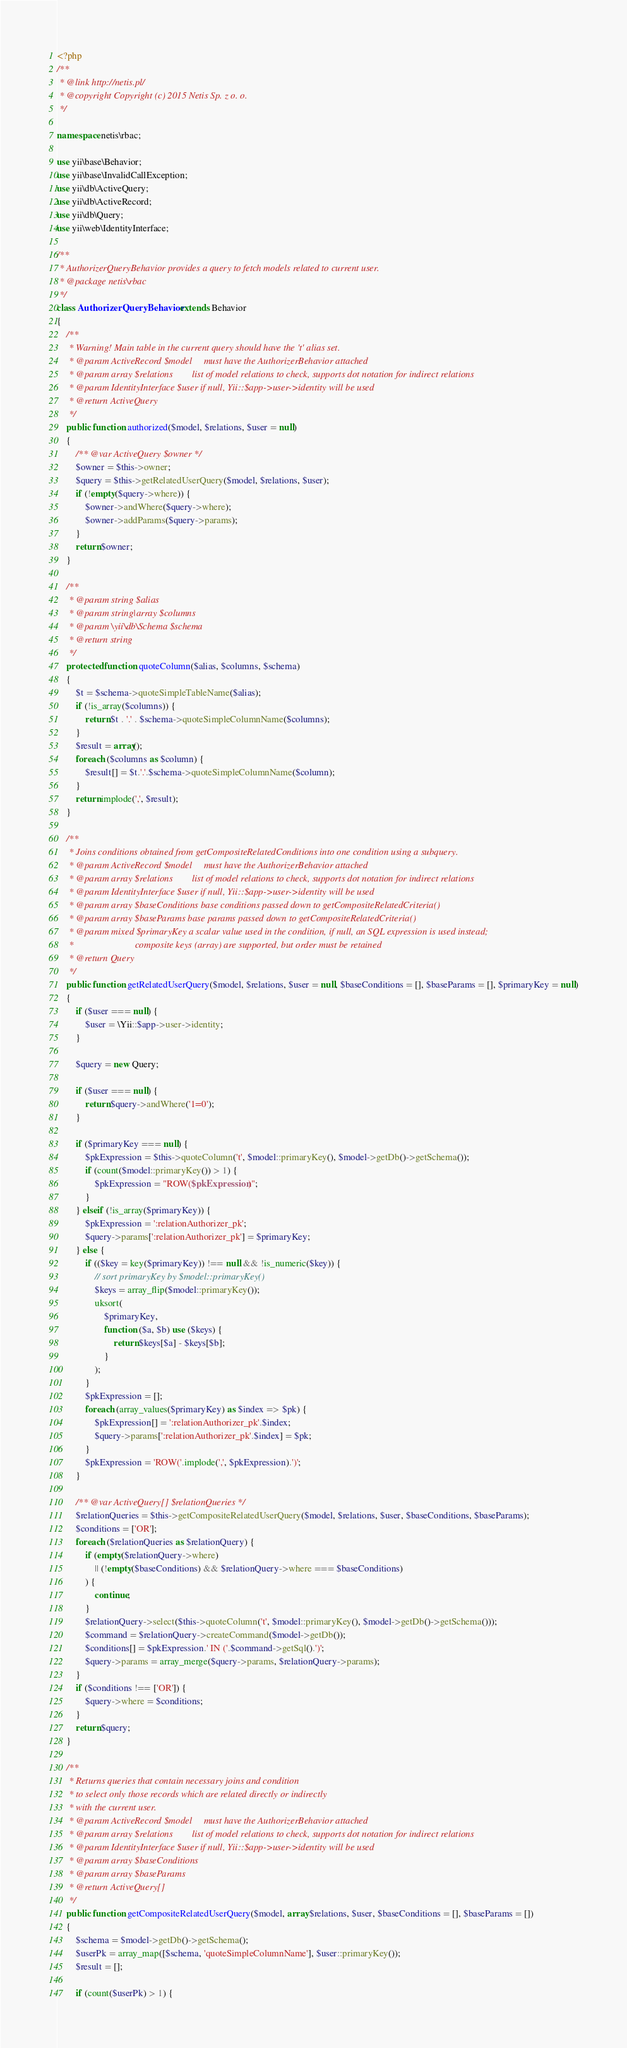Convert code to text. <code><loc_0><loc_0><loc_500><loc_500><_PHP_><?php
/**
 * @link http://netis.pl/
 * @copyright Copyright (c) 2015 Netis Sp. z o. o.
 */

namespace netis\rbac;

use yii\base\Behavior;
use yii\base\InvalidCallException;
use yii\db\ActiveQuery;
use yii\db\ActiveRecord;
use yii\db\Query;
use yii\web\IdentityInterface;

/**
 * AuthorizerQueryBehavior provides a query to fetch models related to current user.
 * @package netis\rbac
 */
class AuthorizerQueryBehavior extends Behavior
{
    /**
     * Warning! Main table in the current query should have the 't' alias set.
     * @param ActiveRecord $model     must have the AuthorizerBehavior attached
     * @param array $relations        list of model relations to check, supports dot notation for indirect relations
     * @param IdentityInterface $user if null, Yii::$app->user->identity will be used
     * @return ActiveQuery
     */
    public function authorized($model, $relations, $user = null)
    {
        /** @var ActiveQuery $owner */
        $owner = $this->owner;
        $query = $this->getRelatedUserQuery($model, $relations, $user);
        if (!empty($query->where)) {
            $owner->andWhere($query->where);
            $owner->addParams($query->params);
        }
        return $owner;
    }

    /**
     * @param string $alias
     * @param string|array $columns
     * @param \yii\db\Schema $schema
     * @return string
     */
    protected function quoteColumn($alias, $columns, $schema)
    {
        $t = $schema->quoteSimpleTableName($alias);
        if (!is_array($columns)) {
            return $t . '.' . $schema->quoteSimpleColumnName($columns);
        }
        $result = array();
        foreach ($columns as $column) {
            $result[] = $t.'.'.$schema->quoteSimpleColumnName($column);
        }
        return implode(',', $result);
    }

    /**
     * Joins conditions obtained from getCompositeRelatedConditions into one condition using a subquery.
     * @param ActiveRecord $model     must have the AuthorizerBehavior attached
     * @param array $relations        list of model relations to check, supports dot notation for indirect relations
     * @param IdentityInterface $user if null, Yii::$app->user->identity will be used
     * @param array $baseConditions base conditions passed down to getCompositeRelatedCriteria()
     * @param array $baseParams base params passed down to getCompositeRelatedCriteria()
     * @param mixed $primaryKey a scalar value used in the condition, if null, an SQL expression is used instead;
     *                          composite keys (array) are supported, but order must be retained
     * @return Query
     */
    public function getRelatedUserQuery($model, $relations, $user = null, $baseConditions = [], $baseParams = [], $primaryKey = null)
    {
        if ($user === null) {
            $user = \Yii::$app->user->identity;
        }

        $query = new Query;

        if ($user === null) {
            return $query->andWhere('1=0');
        }

        if ($primaryKey === null) {
            $pkExpression = $this->quoteColumn('t', $model::primaryKey(), $model->getDb()->getSchema());
            if (count($model::primaryKey()) > 1) {
                $pkExpression = "ROW($pkExpression)";
            }
        } elseif (!is_array($primaryKey)) {
            $pkExpression = ':relationAuthorizer_pk';
            $query->params[':relationAuthorizer_pk'] = $primaryKey;
        } else {
            if (($key = key($primaryKey)) !== null && !is_numeric($key)) {
                // sort primaryKey by $model::primaryKey()
                $keys = array_flip($model::primaryKey());
                uksort(
                    $primaryKey,
                    function ($a, $b) use ($keys) {
                        return $keys[$a] - $keys[$b];
                    }
                );
            }
            $pkExpression = [];
            foreach (array_values($primaryKey) as $index => $pk) {
                $pkExpression[] = ':relationAuthorizer_pk'.$index;
                $query->params[':relationAuthorizer_pk'.$index] = $pk;
            }
            $pkExpression = 'ROW('.implode(',', $pkExpression).')';
        }

        /** @var ActiveQuery[] $relationQueries */
        $relationQueries = $this->getCompositeRelatedUserQuery($model, $relations, $user, $baseConditions, $baseParams);
        $conditions = ['OR'];
        foreach ($relationQueries as $relationQuery) {
            if (empty($relationQuery->where)
                || (!empty($baseConditions) && $relationQuery->where === $baseConditions)
            ) {
                continue;
            }
            $relationQuery->select($this->quoteColumn('t', $model::primaryKey(), $model->getDb()->getSchema()));
            $command = $relationQuery->createCommand($model->getDb());
            $conditions[] = $pkExpression.' IN ('.$command->getSql().')';
            $query->params = array_merge($query->params, $relationQuery->params);
        }
        if ($conditions !== ['OR']) {
            $query->where = $conditions;
        }
        return $query;
    }

    /**
     * Returns queries that contain necessary joins and condition
     * to select only those records which are related directly or indirectly
     * with the current user.
     * @param ActiveRecord $model     must have the AuthorizerBehavior attached
     * @param array $relations        list of model relations to check, supports dot notation for indirect relations
     * @param IdentityInterface $user if null, Yii::$app->user->identity will be used
     * @param array $baseConditions
     * @param array $baseParams
     * @return ActiveQuery[]
     */
    public function getCompositeRelatedUserQuery($model, array $relations, $user, $baseConditions = [], $baseParams = [])
    {
        $schema = $model->getDb()->getSchema();
        $userPk = array_map([$schema, 'quoteSimpleColumnName'], $user::primaryKey());
        $result = [];

        if (count($userPk) > 1) {</code> 